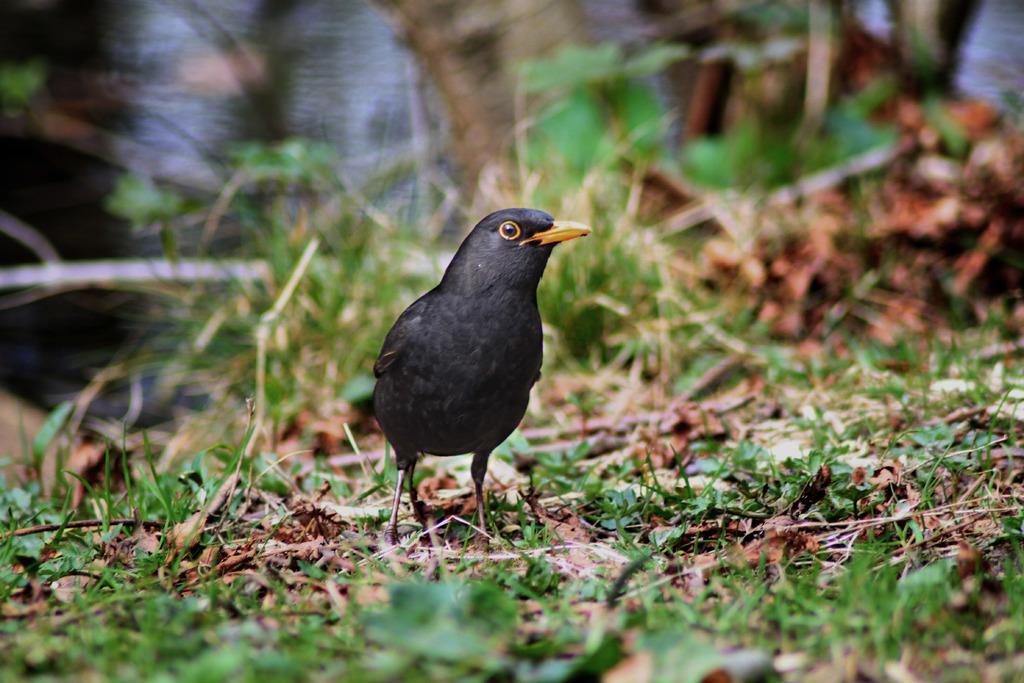Please provide a concise description of this image. In this image I can see grass and I can see black colour bird. I can also see this image is little bit blurry from background. 